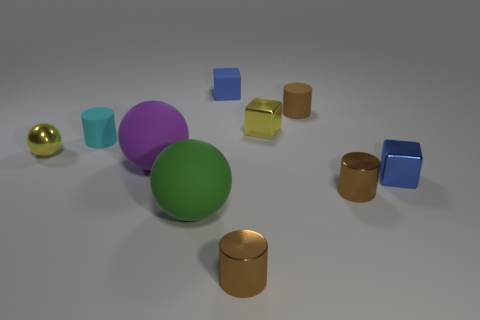Which objects in the scene have reflective surfaces? The objects with reflective surfaces in this image include the small gold sphere, the metal cube, and the two cylinders with metallic finishes—one copper-colored and one blue. 